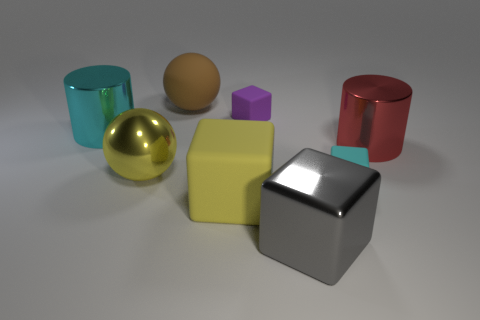Subtract all green balls. Subtract all green cylinders. How many balls are left? 2 Add 1 rubber things. How many objects exist? 9 Subtract all cylinders. How many objects are left? 6 Add 8 yellow shiny cylinders. How many yellow shiny cylinders exist? 8 Subtract 0 blue spheres. How many objects are left? 8 Subtract all yellow things. Subtract all small cyan rubber objects. How many objects are left? 5 Add 2 tiny cubes. How many tiny cubes are left? 4 